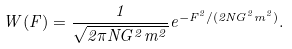Convert formula to latex. <formula><loc_0><loc_0><loc_500><loc_500>W ( F ) = \frac { 1 } { \sqrt { 2 \pi N G ^ { 2 } m ^ { 2 } } } e ^ { - F ^ { 2 } / ( 2 N G ^ { 2 } m ^ { 2 } ) } .</formula> 